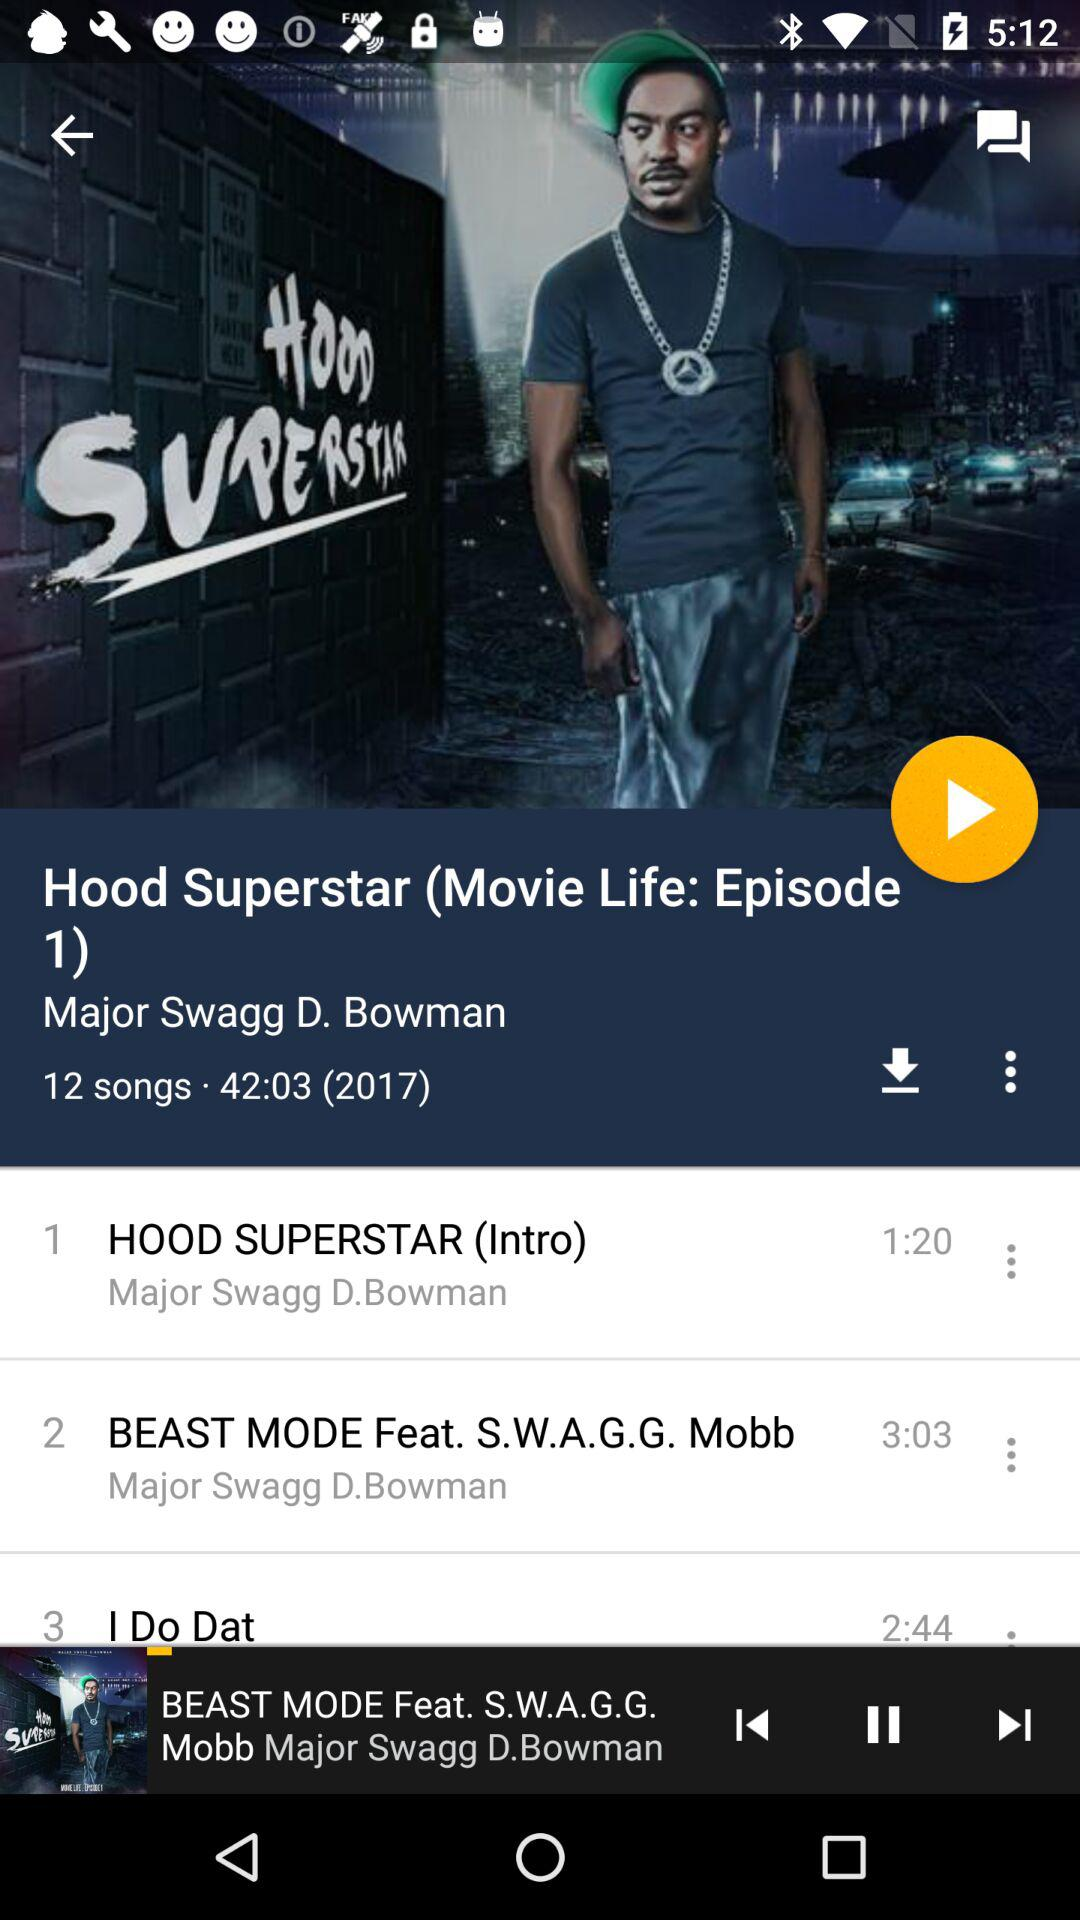What is the duration of "HOOD SUPERSTAR (Intro)"? The duration of "HOOD SUPERSTAR (Intro)" is 1 minute and 20 seconds. 